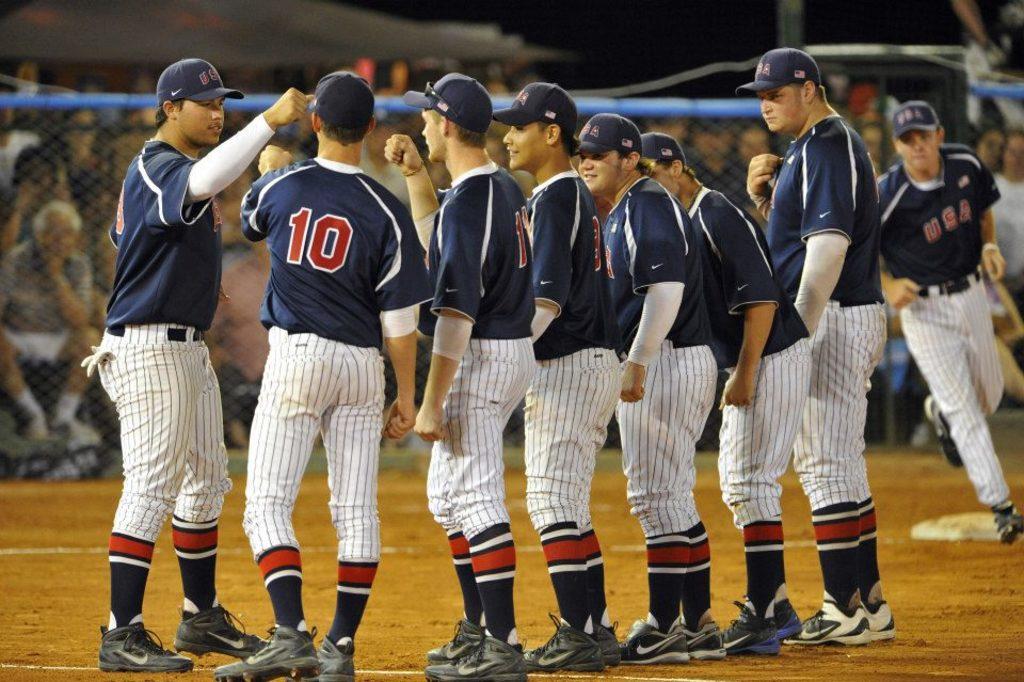What sport are those men about to play?
Offer a very short reply. Answering does not require reading text in the image. 